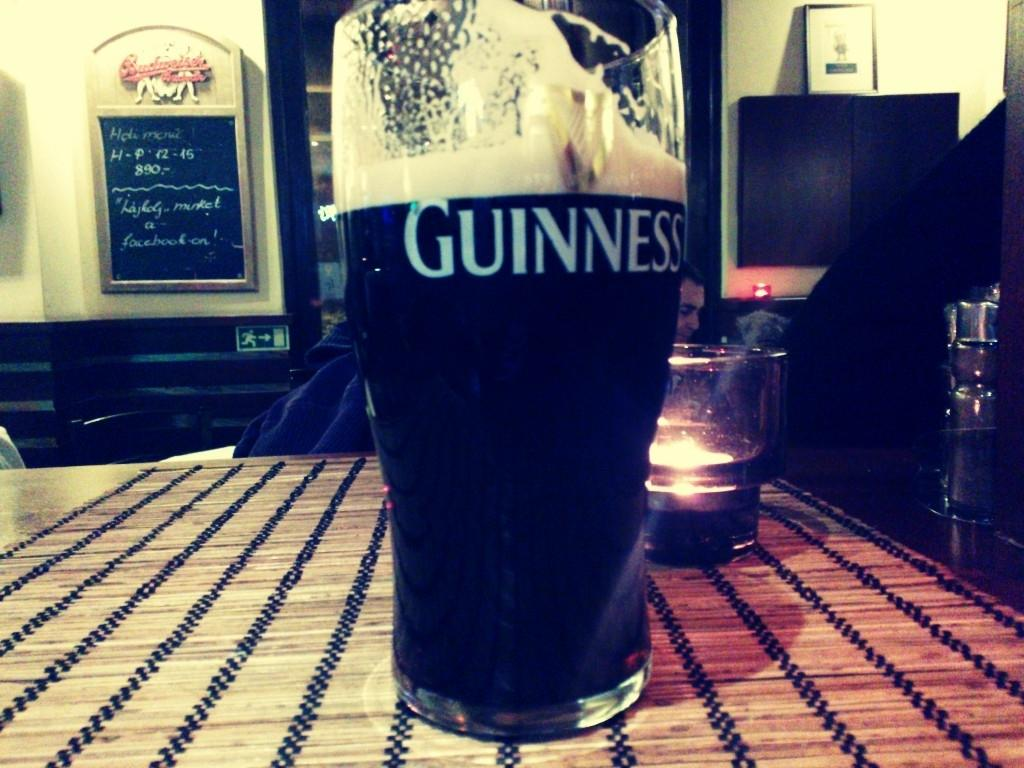<image>
Summarize the visual content of the image. A glass of Guinness is on the table. 